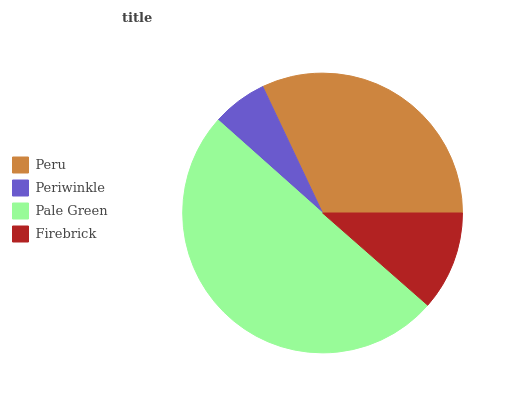Is Periwinkle the minimum?
Answer yes or no. Yes. Is Pale Green the maximum?
Answer yes or no. Yes. Is Pale Green the minimum?
Answer yes or no. No. Is Periwinkle the maximum?
Answer yes or no. No. Is Pale Green greater than Periwinkle?
Answer yes or no. Yes. Is Periwinkle less than Pale Green?
Answer yes or no. Yes. Is Periwinkle greater than Pale Green?
Answer yes or no. No. Is Pale Green less than Periwinkle?
Answer yes or no. No. Is Peru the high median?
Answer yes or no. Yes. Is Firebrick the low median?
Answer yes or no. Yes. Is Pale Green the high median?
Answer yes or no. No. Is Pale Green the low median?
Answer yes or no. No. 